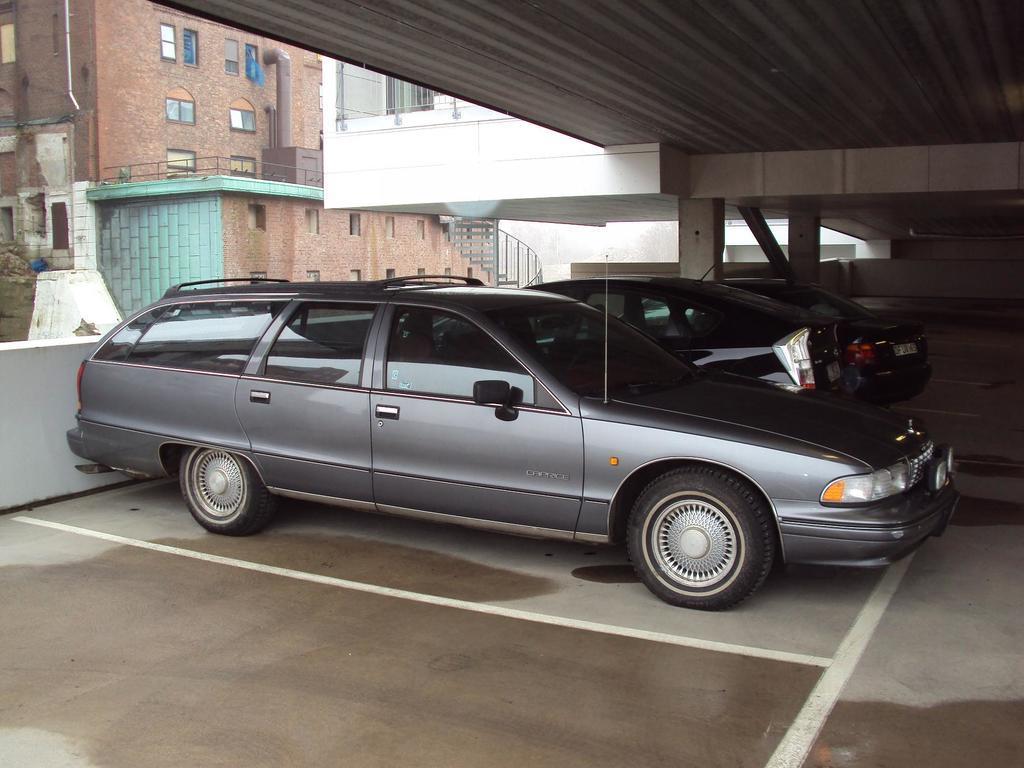Describe this image in one or two sentences. In this image there are few cars parked, beside the cars there are pillars, on top of the cars there is a rooftop, beside the cars there is a concrete fence, on the other side of the fence there are buildings. 